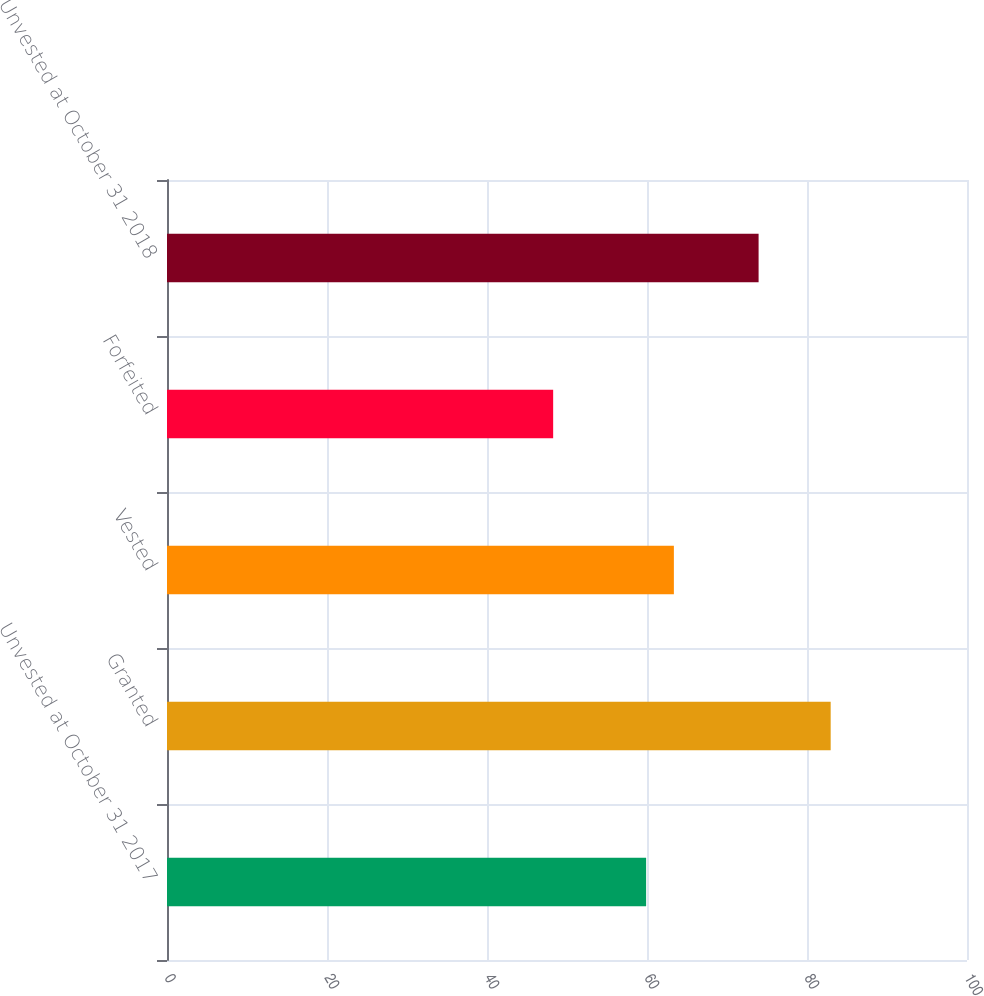<chart> <loc_0><loc_0><loc_500><loc_500><bar_chart><fcel>Unvested at October 31 2017<fcel>Granted<fcel>Vested<fcel>Forfeited<fcel>Unvested at October 31 2018<nl><fcel>59.89<fcel>82.96<fcel>63.36<fcel>48.27<fcel>73.95<nl></chart> 